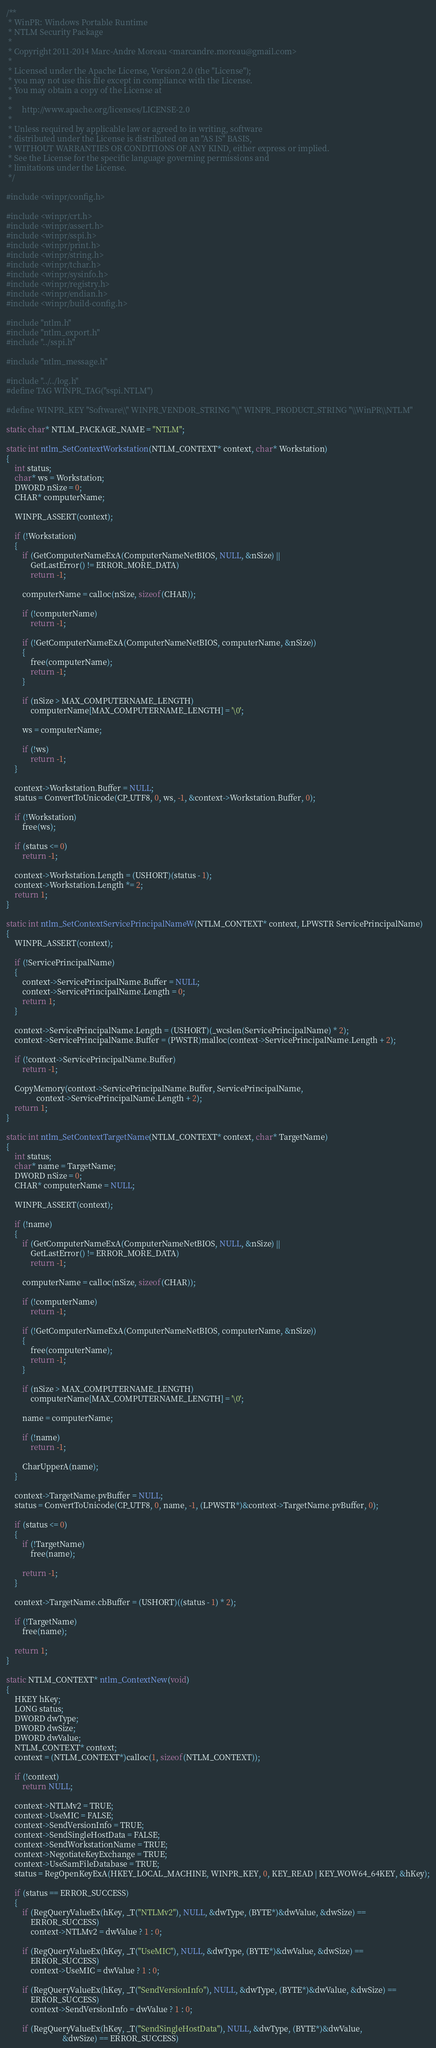<code> <loc_0><loc_0><loc_500><loc_500><_C_>/**
 * WinPR: Windows Portable Runtime
 * NTLM Security Package
 *
 * Copyright 2011-2014 Marc-Andre Moreau <marcandre.moreau@gmail.com>
 *
 * Licensed under the Apache License, Version 2.0 (the "License");
 * you may not use this file except in compliance with the License.
 * You may obtain a copy of the License at
 *
 *     http://www.apache.org/licenses/LICENSE-2.0
 *
 * Unless required by applicable law or agreed to in writing, software
 * distributed under the License is distributed on an "AS IS" BASIS,
 * WITHOUT WARRANTIES OR CONDITIONS OF ANY KIND, either express or implied.
 * See the License for the specific language governing permissions and
 * limitations under the License.
 */

#include <winpr/config.h>

#include <winpr/crt.h>
#include <winpr/assert.h>
#include <winpr/sspi.h>
#include <winpr/print.h>
#include <winpr/string.h>
#include <winpr/tchar.h>
#include <winpr/sysinfo.h>
#include <winpr/registry.h>
#include <winpr/endian.h>
#include <winpr/build-config.h>

#include "ntlm.h"
#include "ntlm_export.h"
#include "../sspi.h"

#include "ntlm_message.h"

#include "../../log.h"
#define TAG WINPR_TAG("sspi.NTLM")

#define WINPR_KEY "Software\\" WINPR_VENDOR_STRING "\\" WINPR_PRODUCT_STRING "\\WinPR\\NTLM"

static char* NTLM_PACKAGE_NAME = "NTLM";

static int ntlm_SetContextWorkstation(NTLM_CONTEXT* context, char* Workstation)
{
	int status;
	char* ws = Workstation;
	DWORD nSize = 0;
	CHAR* computerName;

	WINPR_ASSERT(context);

	if (!Workstation)
	{
		if (GetComputerNameExA(ComputerNameNetBIOS, NULL, &nSize) ||
		    GetLastError() != ERROR_MORE_DATA)
			return -1;

		computerName = calloc(nSize, sizeof(CHAR));

		if (!computerName)
			return -1;

		if (!GetComputerNameExA(ComputerNameNetBIOS, computerName, &nSize))
		{
			free(computerName);
			return -1;
		}

		if (nSize > MAX_COMPUTERNAME_LENGTH)
			computerName[MAX_COMPUTERNAME_LENGTH] = '\0';

		ws = computerName;

		if (!ws)
			return -1;
	}

	context->Workstation.Buffer = NULL;
	status = ConvertToUnicode(CP_UTF8, 0, ws, -1, &context->Workstation.Buffer, 0);

	if (!Workstation)
		free(ws);

	if (status <= 0)
		return -1;

	context->Workstation.Length = (USHORT)(status - 1);
	context->Workstation.Length *= 2;
	return 1;
}

static int ntlm_SetContextServicePrincipalNameW(NTLM_CONTEXT* context, LPWSTR ServicePrincipalName)
{
	WINPR_ASSERT(context);

	if (!ServicePrincipalName)
	{
		context->ServicePrincipalName.Buffer = NULL;
		context->ServicePrincipalName.Length = 0;
		return 1;
	}

	context->ServicePrincipalName.Length = (USHORT)(_wcslen(ServicePrincipalName) * 2);
	context->ServicePrincipalName.Buffer = (PWSTR)malloc(context->ServicePrincipalName.Length + 2);

	if (!context->ServicePrincipalName.Buffer)
		return -1;

	CopyMemory(context->ServicePrincipalName.Buffer, ServicePrincipalName,
	           context->ServicePrincipalName.Length + 2);
	return 1;
}

static int ntlm_SetContextTargetName(NTLM_CONTEXT* context, char* TargetName)
{
	int status;
	char* name = TargetName;
	DWORD nSize = 0;
	CHAR* computerName = NULL;

	WINPR_ASSERT(context);

	if (!name)
	{
		if (GetComputerNameExA(ComputerNameNetBIOS, NULL, &nSize) ||
		    GetLastError() != ERROR_MORE_DATA)
			return -1;

		computerName = calloc(nSize, sizeof(CHAR));

		if (!computerName)
			return -1;

		if (!GetComputerNameExA(ComputerNameNetBIOS, computerName, &nSize))
		{
			free(computerName);
			return -1;
		}

		if (nSize > MAX_COMPUTERNAME_LENGTH)
			computerName[MAX_COMPUTERNAME_LENGTH] = '\0';

		name = computerName;

		if (!name)
			return -1;

		CharUpperA(name);
	}

	context->TargetName.pvBuffer = NULL;
	status = ConvertToUnicode(CP_UTF8, 0, name, -1, (LPWSTR*)&context->TargetName.pvBuffer, 0);

	if (status <= 0)
	{
		if (!TargetName)
			free(name);

		return -1;
	}

	context->TargetName.cbBuffer = (USHORT)((status - 1) * 2);

	if (!TargetName)
		free(name);

	return 1;
}

static NTLM_CONTEXT* ntlm_ContextNew(void)
{
	HKEY hKey;
	LONG status;
	DWORD dwType;
	DWORD dwSize;
	DWORD dwValue;
	NTLM_CONTEXT* context;
	context = (NTLM_CONTEXT*)calloc(1, sizeof(NTLM_CONTEXT));

	if (!context)
		return NULL;

	context->NTLMv2 = TRUE;
	context->UseMIC = FALSE;
	context->SendVersionInfo = TRUE;
	context->SendSingleHostData = FALSE;
	context->SendWorkstationName = TRUE;
	context->NegotiateKeyExchange = TRUE;
	context->UseSamFileDatabase = TRUE;
	status = RegOpenKeyExA(HKEY_LOCAL_MACHINE, WINPR_KEY, 0, KEY_READ | KEY_WOW64_64KEY, &hKey);

	if (status == ERROR_SUCCESS)
	{
		if (RegQueryValueEx(hKey, _T("NTLMv2"), NULL, &dwType, (BYTE*)&dwValue, &dwSize) ==
		    ERROR_SUCCESS)
			context->NTLMv2 = dwValue ? 1 : 0;

		if (RegQueryValueEx(hKey, _T("UseMIC"), NULL, &dwType, (BYTE*)&dwValue, &dwSize) ==
		    ERROR_SUCCESS)
			context->UseMIC = dwValue ? 1 : 0;

		if (RegQueryValueEx(hKey, _T("SendVersionInfo"), NULL, &dwType, (BYTE*)&dwValue, &dwSize) ==
		    ERROR_SUCCESS)
			context->SendVersionInfo = dwValue ? 1 : 0;

		if (RegQueryValueEx(hKey, _T("SendSingleHostData"), NULL, &dwType, (BYTE*)&dwValue,
		                    &dwSize) == ERROR_SUCCESS)</code> 